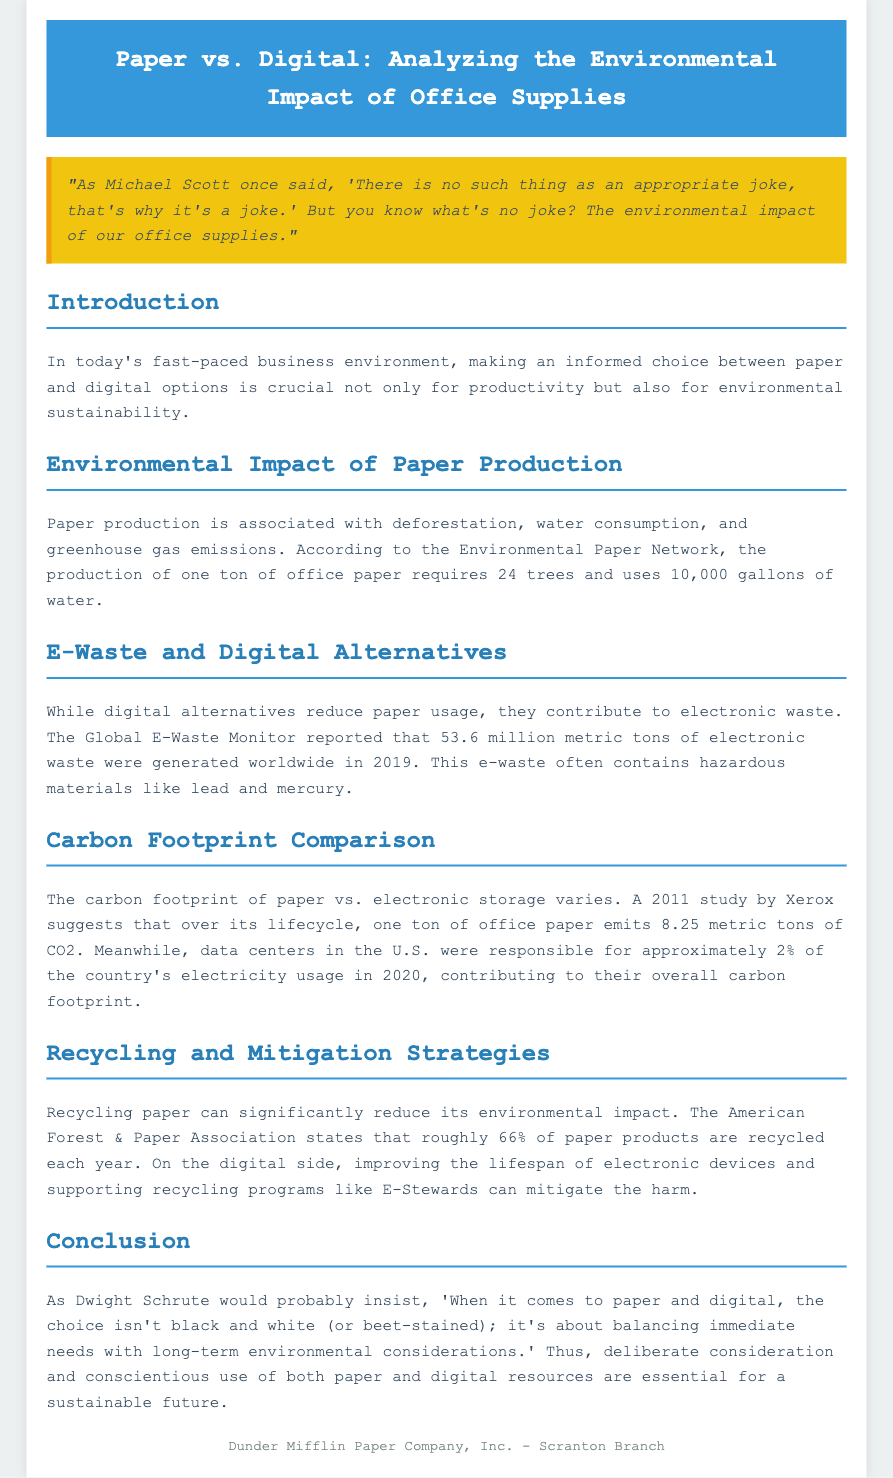What is the main focus of the paper? The main focus is the analysis of the environmental impact of paper compared to digital office supplies.
Answer: Environmental impact of office supplies How many trees are required to produce one ton of office paper? The document states that the production of one ton of office paper requires 24 trees.
Answer: 24 trees What was the generation of electronic waste worldwide in 2019? The Global E-Waste Monitor reported 53.6 million metric tons of electronic waste generated worldwide in 2019.
Answer: 53.6 million metric tons What percentage of paper products are recycled each year? According to the American Forest & Paper Association, roughly 66% of paper products are recycled each year.
Answer: 66% What is one harmful material commonly found in e-waste? The document mentions that e-waste often contains hazardous materials like lead and mercury, specifying lead as one.
Answer: Lead According to a 2011 study by Xerox, how much CO2 does one ton of office paper emit over its lifecycle? The study suggests that one ton of office paper emits 8.25 metric tons of CO2 over its lifecycle.
Answer: 8.25 metric tons What contribution did data centers in the U.S. make to the country's electricity usage in 2020? The document states that data centers were responsible for approximately 2% of the country's electricity usage in 2020.
Answer: 2% Which organization's recycling programs can help mitigate the harm of electronic waste? The document mentions supporting recycling programs like E-Stewards to mitigate the harm of electronic waste.
Answer: E-Stewards What quote from Michael Scott is mentioned in the document? The document quotes Michael Scott's observation about appropriate jokes in connection to environmental impact.
Answer: "There is no such thing as an appropriate joke, that's why it's a joke." 